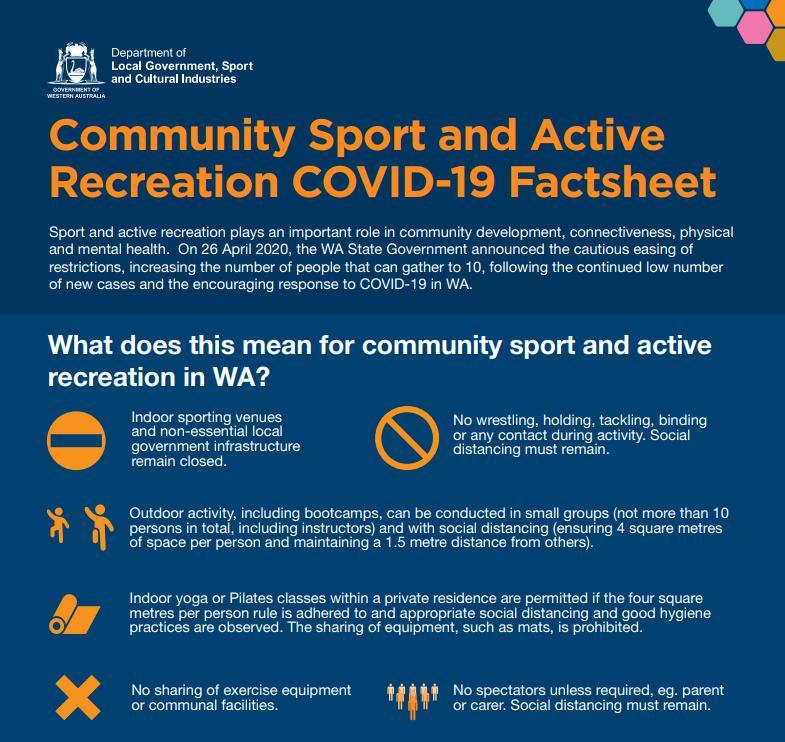For social distancing what area should be between persons?
Answer the question with a short phrase. 4 square metres of space 